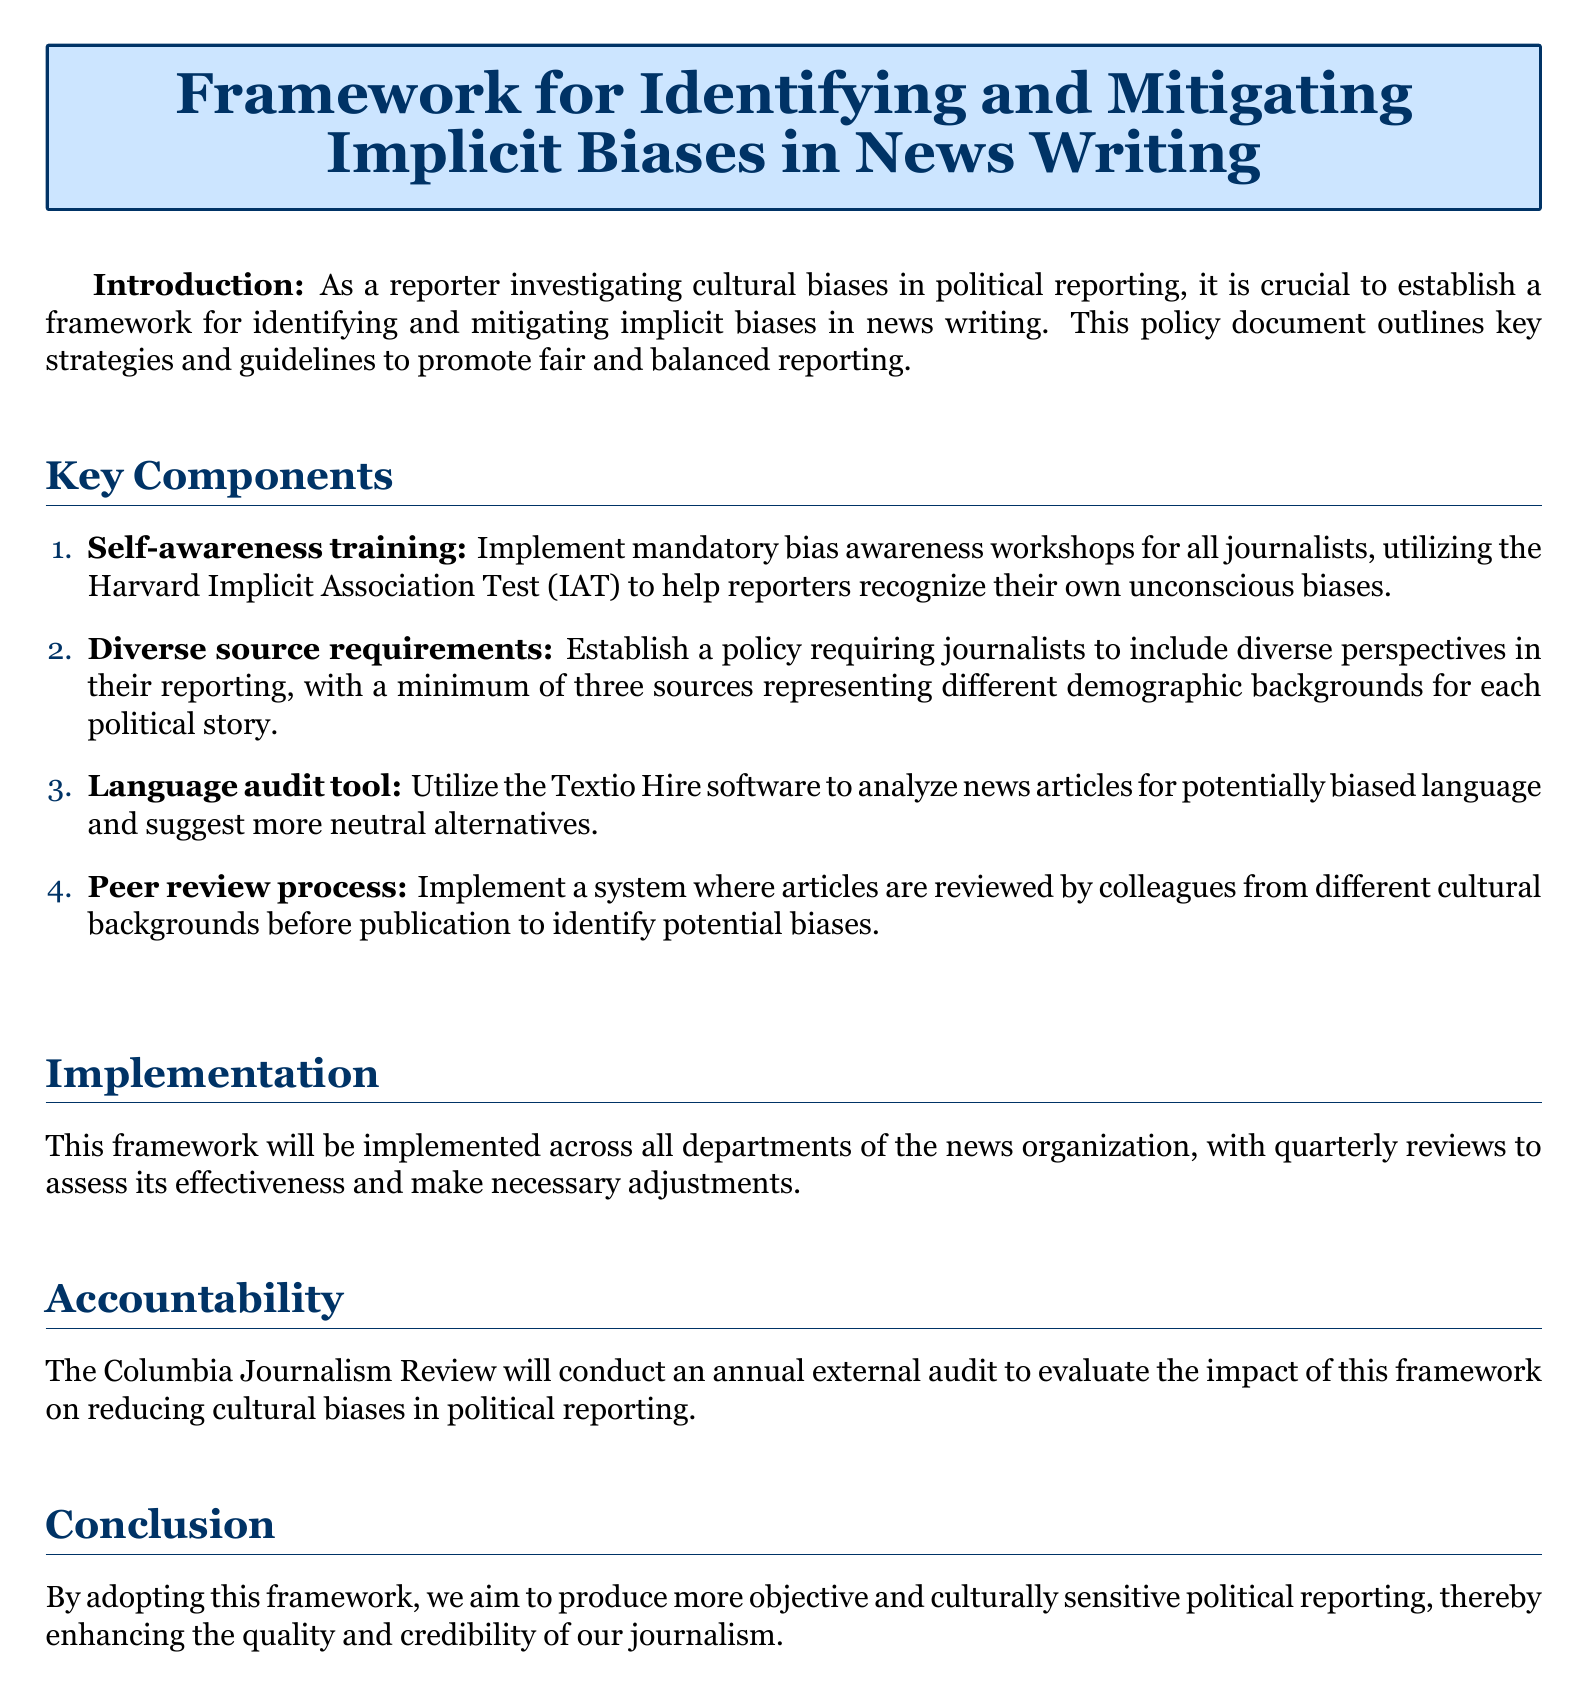What is the title of the document? The title is explicitly stated at the beginning of the document, providing an overview of its content.
Answer: Framework for Identifying and Mitigating Implicit Biases in News Writing How many key components are outlined in the document? The document lists the number of components included in the key components section.
Answer: 4 What is the first key component mentioned? The first item in the enumerated list describes the initial strategy for addressing bias in news reporting.
Answer: Self-awareness training What software is recommended for language audits? The document specifies a particular software tool used to analyze biased language in news articles.
Answer: Textio Hire What will be conducted annually to assess the framework's impact? The document mentions an external audit aimed at evaluating the effectiveness of the proposed framework.
Answer: Annual external audit How often will the implementation reviews occur? The document states the frequency of reviews to assess the implementation of the framework.
Answer: Quarterly Which organization will conduct the external audit? The document identifies the organization responsible for the annual audit mentioned in the accountability section.
Answer: Columbia Journalism Review What is the purpose of implementing the peer review process? The document explains the role of this process in relation to identifying biases before publication.
Answer: Identify potential biases What is one outcome the framework aims to achieve? The conclusion provides an overarching goal of the framework regarding the journalism produced.
Answer: Objective and culturally sensitive political reporting 